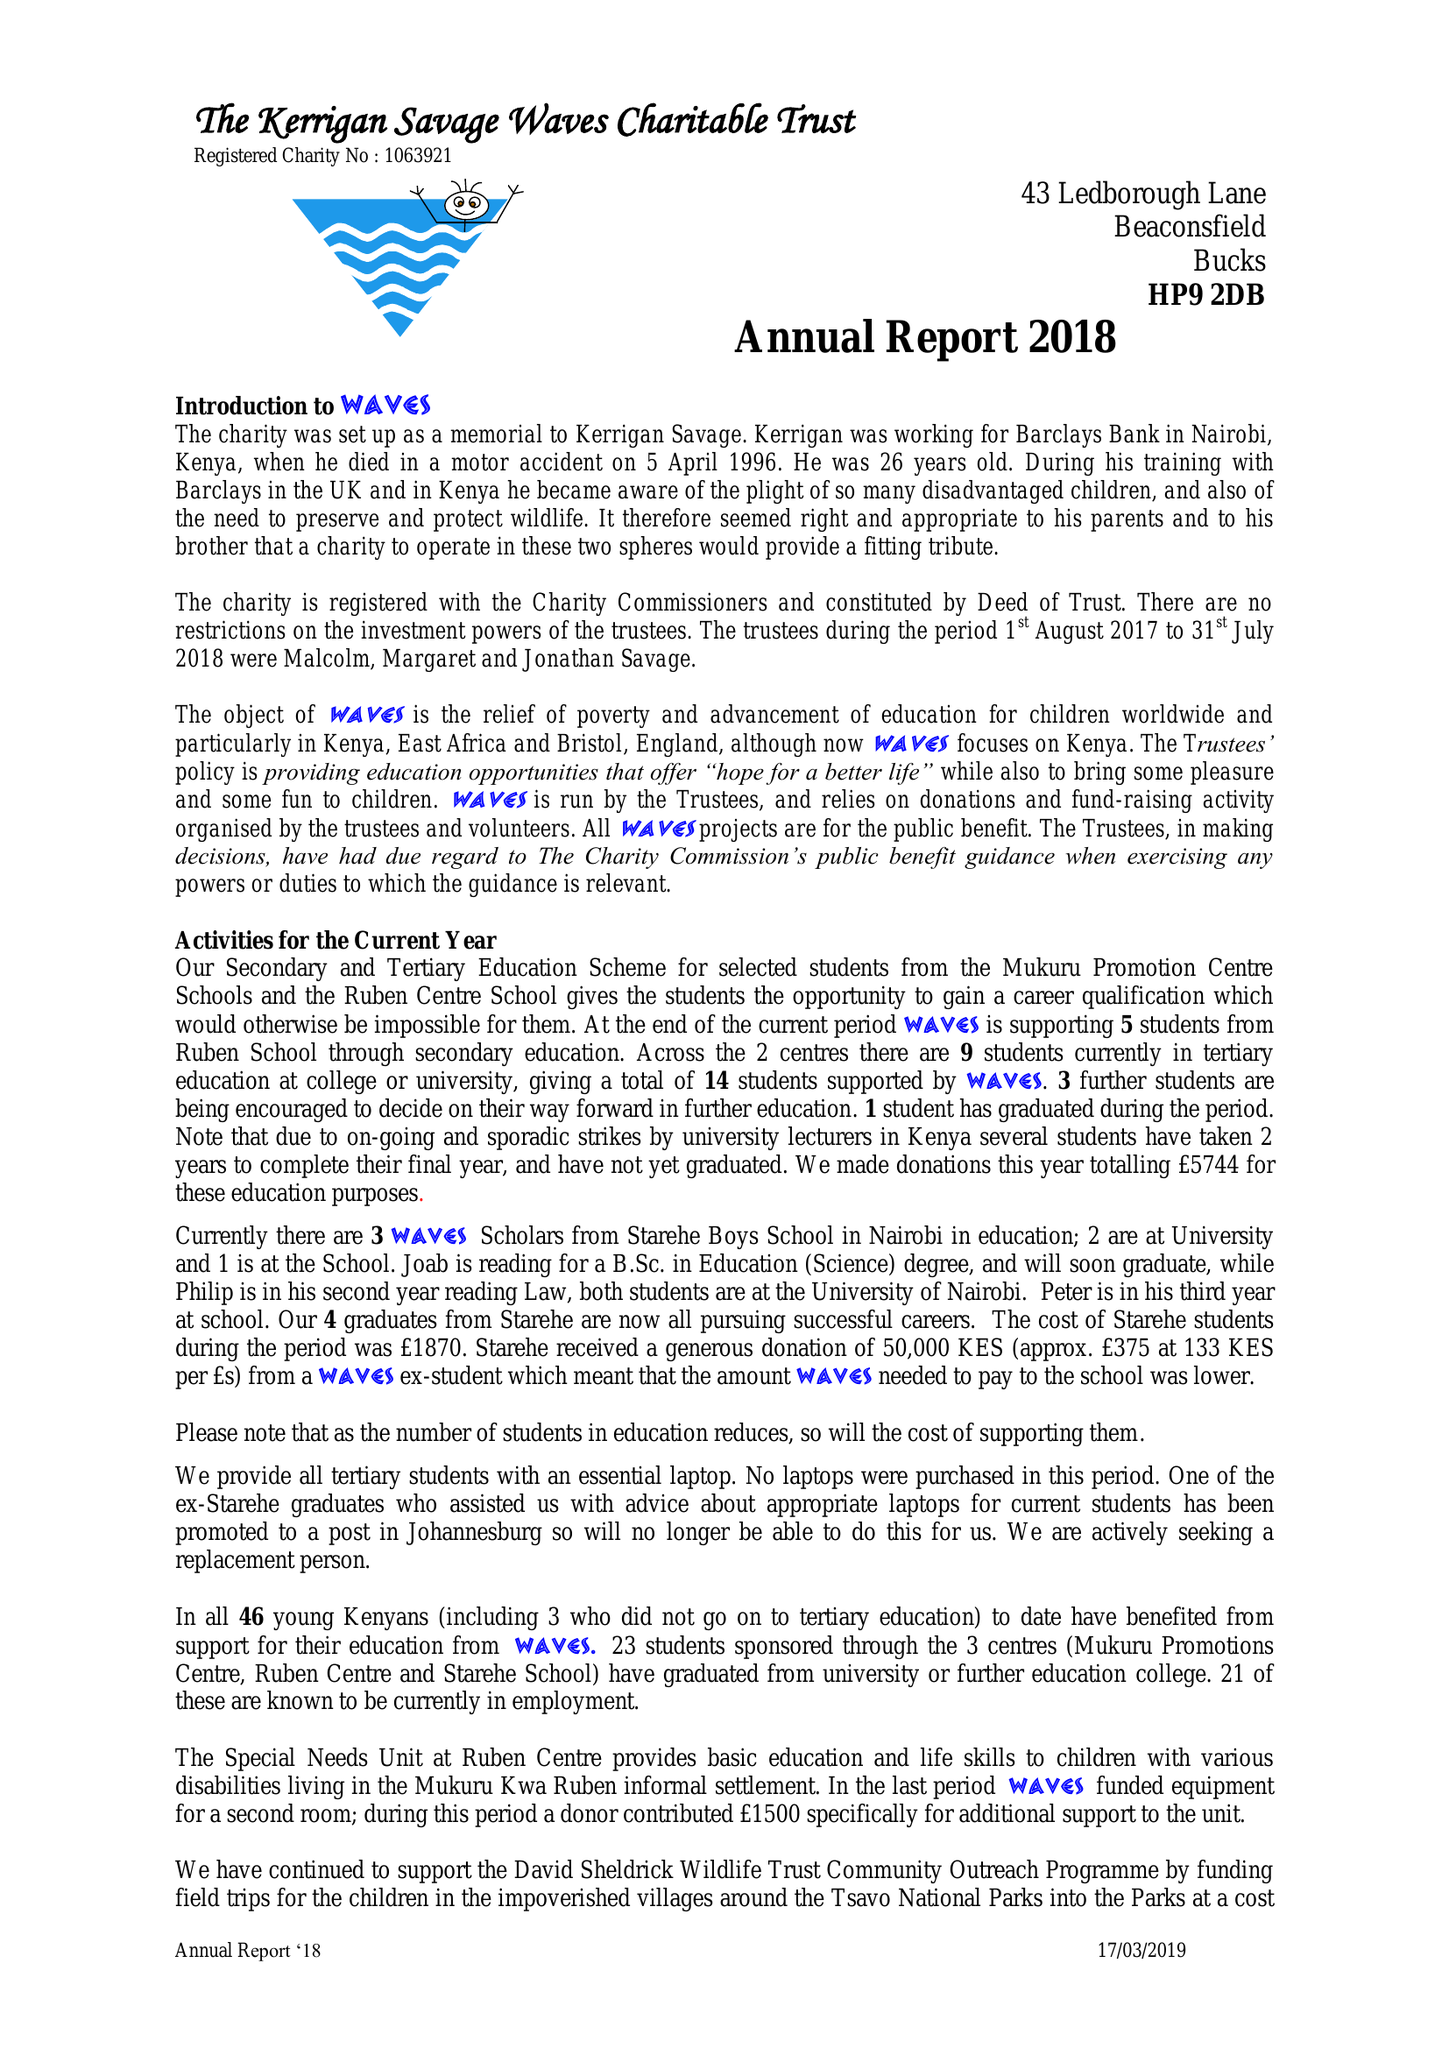What is the value for the charity_name?
Answer the question using a single word or phrase. Kerrigan Savage Waves Charitable Trust 